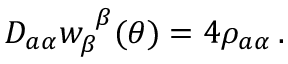Convert formula to latex. <formula><loc_0><loc_0><loc_500><loc_500>D _ { a \alpha } w _ { \beta } ^ { \beta } ( \theta ) = 4 \rho _ { a \alpha } \, .</formula> 